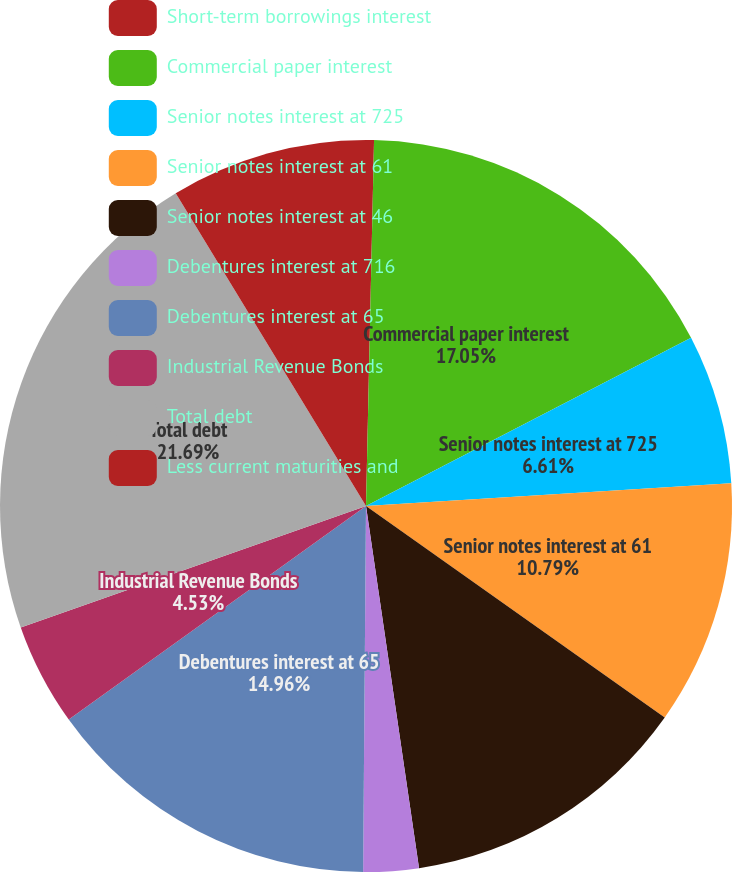<chart> <loc_0><loc_0><loc_500><loc_500><pie_chart><fcel>Short-term borrowings interest<fcel>Commercial paper interest<fcel>Senior notes interest at 725<fcel>Senior notes interest at 61<fcel>Senior notes interest at 46<fcel>Debentures interest at 716<fcel>Debentures interest at 65<fcel>Industrial Revenue Bonds<fcel>Total debt<fcel>Less current maturities and<nl><fcel>0.35%<fcel>17.05%<fcel>6.61%<fcel>10.79%<fcel>12.88%<fcel>2.44%<fcel>14.96%<fcel>4.53%<fcel>21.68%<fcel>8.7%<nl></chart> 